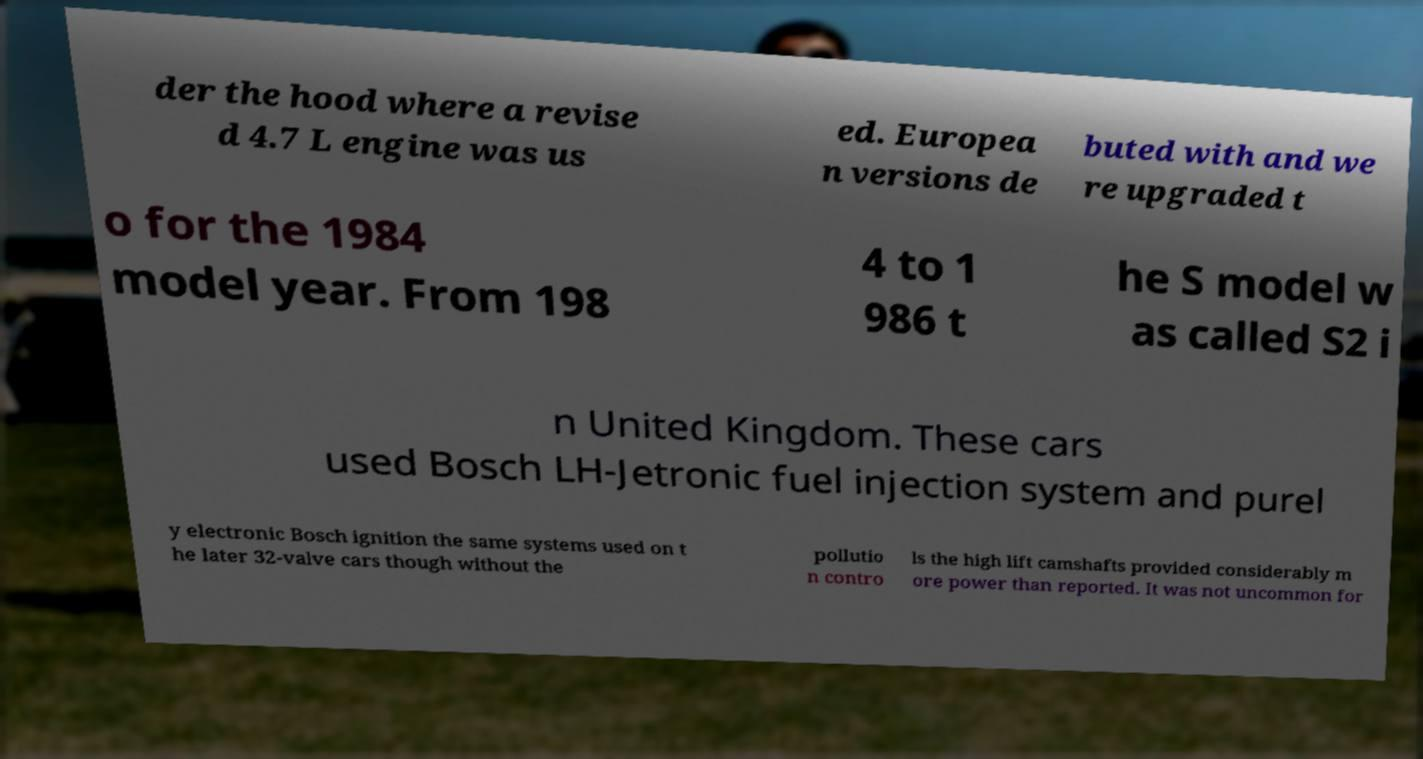Can you read and provide the text displayed in the image?This photo seems to have some interesting text. Can you extract and type it out for me? der the hood where a revise d 4.7 L engine was us ed. Europea n versions de buted with and we re upgraded t o for the 1984 model year. From 198 4 to 1 986 t he S model w as called S2 i n United Kingdom. These cars used Bosch LH-Jetronic fuel injection system and purel y electronic Bosch ignition the same systems used on t he later 32-valve cars though without the pollutio n contro ls the high lift camshafts provided considerably m ore power than reported. It was not uncommon for 